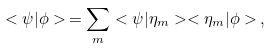<formula> <loc_0><loc_0><loc_500><loc_500>< \psi | \phi > \, = \sum _ { m } < \psi | \eta _ { m } > < \eta _ { m } | \phi > \, ,</formula> 